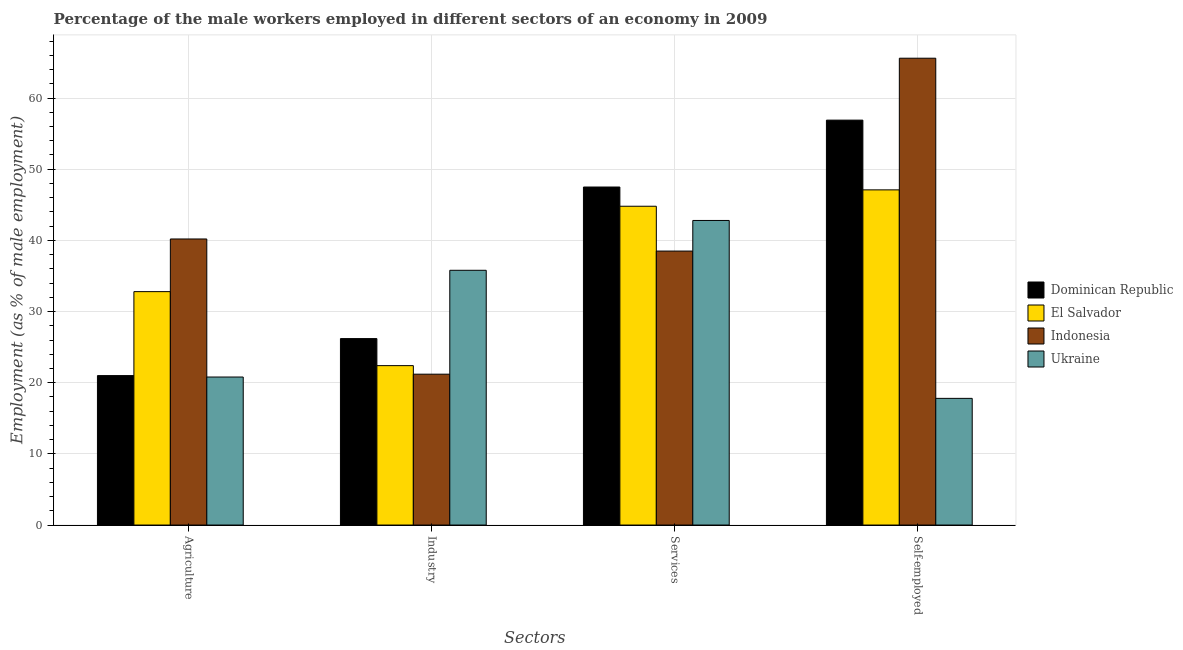How many different coloured bars are there?
Your response must be concise. 4. How many groups of bars are there?
Your response must be concise. 4. Are the number of bars per tick equal to the number of legend labels?
Offer a terse response. Yes. Are the number of bars on each tick of the X-axis equal?
Your answer should be very brief. Yes. What is the label of the 3rd group of bars from the left?
Offer a very short reply. Services. What is the percentage of male workers in services in Dominican Republic?
Ensure brevity in your answer.  47.5. Across all countries, what is the maximum percentage of male workers in services?
Offer a very short reply. 47.5. Across all countries, what is the minimum percentage of self employed male workers?
Offer a terse response. 17.8. In which country was the percentage of male workers in agriculture maximum?
Your response must be concise. Indonesia. In which country was the percentage of male workers in agriculture minimum?
Ensure brevity in your answer.  Ukraine. What is the total percentage of male workers in services in the graph?
Provide a succinct answer. 173.6. What is the difference between the percentage of male workers in agriculture in El Salvador and that in Indonesia?
Make the answer very short. -7.4. What is the difference between the percentage of male workers in industry in Indonesia and the percentage of male workers in services in Ukraine?
Keep it short and to the point. -21.6. What is the average percentage of male workers in agriculture per country?
Offer a terse response. 28.7. What is the difference between the percentage of self employed male workers and percentage of male workers in services in Indonesia?
Your answer should be compact. 27.1. What is the ratio of the percentage of male workers in services in El Salvador to that in Indonesia?
Keep it short and to the point. 1.16. Is the difference between the percentage of male workers in agriculture in Indonesia and Dominican Republic greater than the difference between the percentage of male workers in industry in Indonesia and Dominican Republic?
Give a very brief answer. Yes. What is the difference between the highest and the second highest percentage of male workers in agriculture?
Offer a terse response. 7.4. What is the difference between the highest and the lowest percentage of male workers in industry?
Your answer should be compact. 14.6. In how many countries, is the percentage of male workers in agriculture greater than the average percentage of male workers in agriculture taken over all countries?
Offer a very short reply. 2. Is the sum of the percentage of male workers in services in El Salvador and Ukraine greater than the maximum percentage of male workers in agriculture across all countries?
Your answer should be very brief. Yes. What does the 1st bar from the left in Services represents?
Your response must be concise. Dominican Republic. What does the 4th bar from the right in Industry represents?
Your answer should be very brief. Dominican Republic. What is the difference between two consecutive major ticks on the Y-axis?
Your response must be concise. 10. Are the values on the major ticks of Y-axis written in scientific E-notation?
Ensure brevity in your answer.  No. Does the graph contain grids?
Your answer should be compact. Yes. How many legend labels are there?
Offer a terse response. 4. How are the legend labels stacked?
Provide a succinct answer. Vertical. What is the title of the graph?
Your answer should be compact. Percentage of the male workers employed in different sectors of an economy in 2009. What is the label or title of the X-axis?
Keep it short and to the point. Sectors. What is the label or title of the Y-axis?
Your answer should be compact. Employment (as % of male employment). What is the Employment (as % of male employment) of Dominican Republic in Agriculture?
Provide a short and direct response. 21. What is the Employment (as % of male employment) in El Salvador in Agriculture?
Keep it short and to the point. 32.8. What is the Employment (as % of male employment) of Indonesia in Agriculture?
Give a very brief answer. 40.2. What is the Employment (as % of male employment) in Ukraine in Agriculture?
Provide a succinct answer. 20.8. What is the Employment (as % of male employment) in Dominican Republic in Industry?
Give a very brief answer. 26.2. What is the Employment (as % of male employment) of El Salvador in Industry?
Keep it short and to the point. 22.4. What is the Employment (as % of male employment) of Indonesia in Industry?
Offer a terse response. 21.2. What is the Employment (as % of male employment) of Ukraine in Industry?
Make the answer very short. 35.8. What is the Employment (as % of male employment) of Dominican Republic in Services?
Give a very brief answer. 47.5. What is the Employment (as % of male employment) in El Salvador in Services?
Your answer should be compact. 44.8. What is the Employment (as % of male employment) of Indonesia in Services?
Keep it short and to the point. 38.5. What is the Employment (as % of male employment) of Ukraine in Services?
Keep it short and to the point. 42.8. What is the Employment (as % of male employment) in Dominican Republic in Self-employed?
Your response must be concise. 56.9. What is the Employment (as % of male employment) in El Salvador in Self-employed?
Make the answer very short. 47.1. What is the Employment (as % of male employment) of Indonesia in Self-employed?
Keep it short and to the point. 65.6. What is the Employment (as % of male employment) in Ukraine in Self-employed?
Your answer should be very brief. 17.8. Across all Sectors, what is the maximum Employment (as % of male employment) in Dominican Republic?
Provide a succinct answer. 56.9. Across all Sectors, what is the maximum Employment (as % of male employment) of El Salvador?
Provide a succinct answer. 47.1. Across all Sectors, what is the maximum Employment (as % of male employment) in Indonesia?
Make the answer very short. 65.6. Across all Sectors, what is the maximum Employment (as % of male employment) of Ukraine?
Provide a short and direct response. 42.8. Across all Sectors, what is the minimum Employment (as % of male employment) in Dominican Republic?
Keep it short and to the point. 21. Across all Sectors, what is the minimum Employment (as % of male employment) of El Salvador?
Give a very brief answer. 22.4. Across all Sectors, what is the minimum Employment (as % of male employment) in Indonesia?
Offer a terse response. 21.2. Across all Sectors, what is the minimum Employment (as % of male employment) of Ukraine?
Your response must be concise. 17.8. What is the total Employment (as % of male employment) in Dominican Republic in the graph?
Provide a short and direct response. 151.6. What is the total Employment (as % of male employment) of El Salvador in the graph?
Give a very brief answer. 147.1. What is the total Employment (as % of male employment) of Indonesia in the graph?
Make the answer very short. 165.5. What is the total Employment (as % of male employment) in Ukraine in the graph?
Make the answer very short. 117.2. What is the difference between the Employment (as % of male employment) of Dominican Republic in Agriculture and that in Industry?
Your answer should be compact. -5.2. What is the difference between the Employment (as % of male employment) of Indonesia in Agriculture and that in Industry?
Provide a succinct answer. 19. What is the difference between the Employment (as % of male employment) of Dominican Republic in Agriculture and that in Services?
Provide a succinct answer. -26.5. What is the difference between the Employment (as % of male employment) of El Salvador in Agriculture and that in Services?
Offer a terse response. -12. What is the difference between the Employment (as % of male employment) of Indonesia in Agriculture and that in Services?
Your answer should be very brief. 1.7. What is the difference between the Employment (as % of male employment) of Dominican Republic in Agriculture and that in Self-employed?
Your answer should be very brief. -35.9. What is the difference between the Employment (as % of male employment) in El Salvador in Agriculture and that in Self-employed?
Your answer should be compact. -14.3. What is the difference between the Employment (as % of male employment) in Indonesia in Agriculture and that in Self-employed?
Your response must be concise. -25.4. What is the difference between the Employment (as % of male employment) in Ukraine in Agriculture and that in Self-employed?
Provide a short and direct response. 3. What is the difference between the Employment (as % of male employment) of Dominican Republic in Industry and that in Services?
Your answer should be compact. -21.3. What is the difference between the Employment (as % of male employment) in El Salvador in Industry and that in Services?
Your answer should be very brief. -22.4. What is the difference between the Employment (as % of male employment) in Indonesia in Industry and that in Services?
Provide a succinct answer. -17.3. What is the difference between the Employment (as % of male employment) in Dominican Republic in Industry and that in Self-employed?
Your answer should be very brief. -30.7. What is the difference between the Employment (as % of male employment) in El Salvador in Industry and that in Self-employed?
Offer a terse response. -24.7. What is the difference between the Employment (as % of male employment) of Indonesia in Industry and that in Self-employed?
Your answer should be compact. -44.4. What is the difference between the Employment (as % of male employment) in Ukraine in Industry and that in Self-employed?
Offer a terse response. 18. What is the difference between the Employment (as % of male employment) in Indonesia in Services and that in Self-employed?
Provide a succinct answer. -27.1. What is the difference between the Employment (as % of male employment) of Ukraine in Services and that in Self-employed?
Make the answer very short. 25. What is the difference between the Employment (as % of male employment) in Dominican Republic in Agriculture and the Employment (as % of male employment) in El Salvador in Industry?
Offer a very short reply. -1.4. What is the difference between the Employment (as % of male employment) of Dominican Republic in Agriculture and the Employment (as % of male employment) of Indonesia in Industry?
Keep it short and to the point. -0.2. What is the difference between the Employment (as % of male employment) of Dominican Republic in Agriculture and the Employment (as % of male employment) of Ukraine in Industry?
Your answer should be compact. -14.8. What is the difference between the Employment (as % of male employment) of El Salvador in Agriculture and the Employment (as % of male employment) of Ukraine in Industry?
Provide a short and direct response. -3. What is the difference between the Employment (as % of male employment) in Dominican Republic in Agriculture and the Employment (as % of male employment) in El Salvador in Services?
Provide a short and direct response. -23.8. What is the difference between the Employment (as % of male employment) of Dominican Republic in Agriculture and the Employment (as % of male employment) of Indonesia in Services?
Ensure brevity in your answer.  -17.5. What is the difference between the Employment (as % of male employment) of Dominican Republic in Agriculture and the Employment (as % of male employment) of Ukraine in Services?
Provide a short and direct response. -21.8. What is the difference between the Employment (as % of male employment) in Dominican Republic in Agriculture and the Employment (as % of male employment) in El Salvador in Self-employed?
Your response must be concise. -26.1. What is the difference between the Employment (as % of male employment) in Dominican Republic in Agriculture and the Employment (as % of male employment) in Indonesia in Self-employed?
Give a very brief answer. -44.6. What is the difference between the Employment (as % of male employment) in Dominican Republic in Agriculture and the Employment (as % of male employment) in Ukraine in Self-employed?
Your response must be concise. 3.2. What is the difference between the Employment (as % of male employment) in El Salvador in Agriculture and the Employment (as % of male employment) in Indonesia in Self-employed?
Your answer should be very brief. -32.8. What is the difference between the Employment (as % of male employment) in El Salvador in Agriculture and the Employment (as % of male employment) in Ukraine in Self-employed?
Provide a short and direct response. 15. What is the difference between the Employment (as % of male employment) in Indonesia in Agriculture and the Employment (as % of male employment) in Ukraine in Self-employed?
Keep it short and to the point. 22.4. What is the difference between the Employment (as % of male employment) in Dominican Republic in Industry and the Employment (as % of male employment) in El Salvador in Services?
Provide a short and direct response. -18.6. What is the difference between the Employment (as % of male employment) in Dominican Republic in Industry and the Employment (as % of male employment) in Ukraine in Services?
Your response must be concise. -16.6. What is the difference between the Employment (as % of male employment) of El Salvador in Industry and the Employment (as % of male employment) of Indonesia in Services?
Your answer should be very brief. -16.1. What is the difference between the Employment (as % of male employment) of El Salvador in Industry and the Employment (as % of male employment) of Ukraine in Services?
Ensure brevity in your answer.  -20.4. What is the difference between the Employment (as % of male employment) of Indonesia in Industry and the Employment (as % of male employment) of Ukraine in Services?
Keep it short and to the point. -21.6. What is the difference between the Employment (as % of male employment) of Dominican Republic in Industry and the Employment (as % of male employment) of El Salvador in Self-employed?
Keep it short and to the point. -20.9. What is the difference between the Employment (as % of male employment) in Dominican Republic in Industry and the Employment (as % of male employment) in Indonesia in Self-employed?
Provide a succinct answer. -39.4. What is the difference between the Employment (as % of male employment) in Dominican Republic in Industry and the Employment (as % of male employment) in Ukraine in Self-employed?
Make the answer very short. 8.4. What is the difference between the Employment (as % of male employment) of El Salvador in Industry and the Employment (as % of male employment) of Indonesia in Self-employed?
Provide a short and direct response. -43.2. What is the difference between the Employment (as % of male employment) in El Salvador in Industry and the Employment (as % of male employment) in Ukraine in Self-employed?
Give a very brief answer. 4.6. What is the difference between the Employment (as % of male employment) in Indonesia in Industry and the Employment (as % of male employment) in Ukraine in Self-employed?
Keep it short and to the point. 3.4. What is the difference between the Employment (as % of male employment) in Dominican Republic in Services and the Employment (as % of male employment) in El Salvador in Self-employed?
Ensure brevity in your answer.  0.4. What is the difference between the Employment (as % of male employment) of Dominican Republic in Services and the Employment (as % of male employment) of Indonesia in Self-employed?
Offer a terse response. -18.1. What is the difference between the Employment (as % of male employment) of Dominican Republic in Services and the Employment (as % of male employment) of Ukraine in Self-employed?
Your response must be concise. 29.7. What is the difference between the Employment (as % of male employment) of El Salvador in Services and the Employment (as % of male employment) of Indonesia in Self-employed?
Make the answer very short. -20.8. What is the difference between the Employment (as % of male employment) of El Salvador in Services and the Employment (as % of male employment) of Ukraine in Self-employed?
Offer a terse response. 27. What is the difference between the Employment (as % of male employment) in Indonesia in Services and the Employment (as % of male employment) in Ukraine in Self-employed?
Your answer should be very brief. 20.7. What is the average Employment (as % of male employment) in Dominican Republic per Sectors?
Make the answer very short. 37.9. What is the average Employment (as % of male employment) of El Salvador per Sectors?
Make the answer very short. 36.77. What is the average Employment (as % of male employment) in Indonesia per Sectors?
Ensure brevity in your answer.  41.38. What is the average Employment (as % of male employment) in Ukraine per Sectors?
Offer a very short reply. 29.3. What is the difference between the Employment (as % of male employment) of Dominican Republic and Employment (as % of male employment) of Indonesia in Agriculture?
Provide a short and direct response. -19.2. What is the difference between the Employment (as % of male employment) of Indonesia and Employment (as % of male employment) of Ukraine in Agriculture?
Provide a succinct answer. 19.4. What is the difference between the Employment (as % of male employment) of Dominican Republic and Employment (as % of male employment) of Indonesia in Industry?
Your response must be concise. 5. What is the difference between the Employment (as % of male employment) of Dominican Republic and Employment (as % of male employment) of Ukraine in Industry?
Keep it short and to the point. -9.6. What is the difference between the Employment (as % of male employment) of El Salvador and Employment (as % of male employment) of Ukraine in Industry?
Your response must be concise. -13.4. What is the difference between the Employment (as % of male employment) of Indonesia and Employment (as % of male employment) of Ukraine in Industry?
Your answer should be very brief. -14.6. What is the difference between the Employment (as % of male employment) in Dominican Republic and Employment (as % of male employment) in Ukraine in Self-employed?
Give a very brief answer. 39.1. What is the difference between the Employment (as % of male employment) in El Salvador and Employment (as % of male employment) in Indonesia in Self-employed?
Ensure brevity in your answer.  -18.5. What is the difference between the Employment (as % of male employment) in El Salvador and Employment (as % of male employment) in Ukraine in Self-employed?
Give a very brief answer. 29.3. What is the difference between the Employment (as % of male employment) of Indonesia and Employment (as % of male employment) of Ukraine in Self-employed?
Give a very brief answer. 47.8. What is the ratio of the Employment (as % of male employment) of Dominican Republic in Agriculture to that in Industry?
Keep it short and to the point. 0.8. What is the ratio of the Employment (as % of male employment) of El Salvador in Agriculture to that in Industry?
Keep it short and to the point. 1.46. What is the ratio of the Employment (as % of male employment) in Indonesia in Agriculture to that in Industry?
Make the answer very short. 1.9. What is the ratio of the Employment (as % of male employment) of Ukraine in Agriculture to that in Industry?
Your answer should be very brief. 0.58. What is the ratio of the Employment (as % of male employment) of Dominican Republic in Agriculture to that in Services?
Give a very brief answer. 0.44. What is the ratio of the Employment (as % of male employment) in El Salvador in Agriculture to that in Services?
Give a very brief answer. 0.73. What is the ratio of the Employment (as % of male employment) in Indonesia in Agriculture to that in Services?
Ensure brevity in your answer.  1.04. What is the ratio of the Employment (as % of male employment) in Ukraine in Agriculture to that in Services?
Keep it short and to the point. 0.49. What is the ratio of the Employment (as % of male employment) of Dominican Republic in Agriculture to that in Self-employed?
Your answer should be compact. 0.37. What is the ratio of the Employment (as % of male employment) in El Salvador in Agriculture to that in Self-employed?
Provide a succinct answer. 0.7. What is the ratio of the Employment (as % of male employment) of Indonesia in Agriculture to that in Self-employed?
Offer a very short reply. 0.61. What is the ratio of the Employment (as % of male employment) in Ukraine in Agriculture to that in Self-employed?
Offer a terse response. 1.17. What is the ratio of the Employment (as % of male employment) in Dominican Republic in Industry to that in Services?
Provide a short and direct response. 0.55. What is the ratio of the Employment (as % of male employment) of El Salvador in Industry to that in Services?
Your answer should be very brief. 0.5. What is the ratio of the Employment (as % of male employment) of Indonesia in Industry to that in Services?
Keep it short and to the point. 0.55. What is the ratio of the Employment (as % of male employment) of Ukraine in Industry to that in Services?
Give a very brief answer. 0.84. What is the ratio of the Employment (as % of male employment) in Dominican Republic in Industry to that in Self-employed?
Your answer should be compact. 0.46. What is the ratio of the Employment (as % of male employment) in El Salvador in Industry to that in Self-employed?
Your answer should be compact. 0.48. What is the ratio of the Employment (as % of male employment) of Indonesia in Industry to that in Self-employed?
Give a very brief answer. 0.32. What is the ratio of the Employment (as % of male employment) of Ukraine in Industry to that in Self-employed?
Make the answer very short. 2.01. What is the ratio of the Employment (as % of male employment) of Dominican Republic in Services to that in Self-employed?
Provide a succinct answer. 0.83. What is the ratio of the Employment (as % of male employment) in El Salvador in Services to that in Self-employed?
Give a very brief answer. 0.95. What is the ratio of the Employment (as % of male employment) in Indonesia in Services to that in Self-employed?
Provide a short and direct response. 0.59. What is the ratio of the Employment (as % of male employment) of Ukraine in Services to that in Self-employed?
Give a very brief answer. 2.4. What is the difference between the highest and the second highest Employment (as % of male employment) in El Salvador?
Your answer should be compact. 2.3. What is the difference between the highest and the second highest Employment (as % of male employment) of Indonesia?
Your response must be concise. 25.4. What is the difference between the highest and the lowest Employment (as % of male employment) of Dominican Republic?
Give a very brief answer. 35.9. What is the difference between the highest and the lowest Employment (as % of male employment) of El Salvador?
Your answer should be compact. 24.7. What is the difference between the highest and the lowest Employment (as % of male employment) of Indonesia?
Provide a short and direct response. 44.4. 